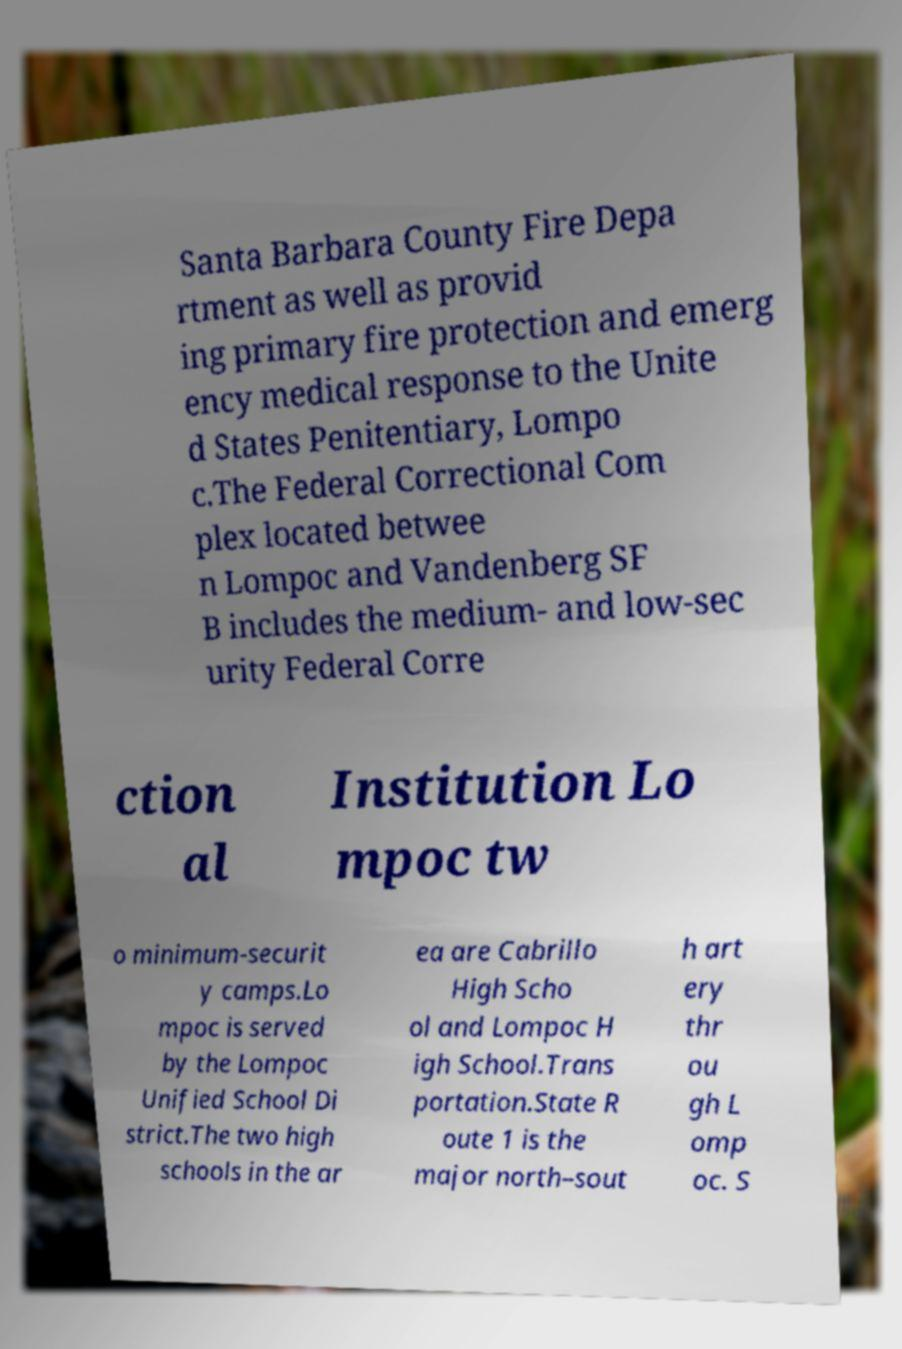Please read and relay the text visible in this image. What does it say? Santa Barbara County Fire Depa rtment as well as provid ing primary fire protection and emerg ency medical response to the Unite d States Penitentiary, Lompo c.The Federal Correctional Com plex located betwee n Lompoc and Vandenberg SF B includes the medium- and low-sec urity Federal Corre ction al Institution Lo mpoc tw o minimum-securit y camps.Lo mpoc is served by the Lompoc Unified School Di strict.The two high schools in the ar ea are Cabrillo High Scho ol and Lompoc H igh School.Trans portation.State R oute 1 is the major north–sout h art ery thr ou gh L omp oc. S 